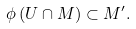Convert formula to latex. <formula><loc_0><loc_0><loc_500><loc_500>\phi \left ( U \cap M \right ) \subset M ^ { \prime } .</formula> 